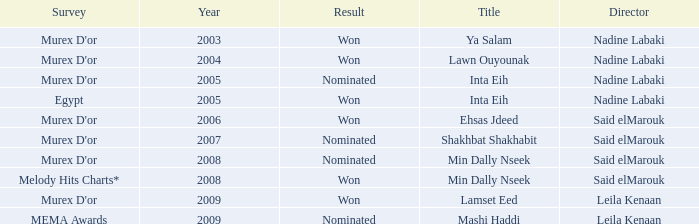What is the title for the Murex D'or survey, after 2005, Said Elmarouk as director, and was nominated? Shakhbat Shakhabit, Min Dally Nseek. 